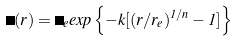<formula> <loc_0><loc_0><loc_500><loc_500>\Sigma ( r ) = \Sigma _ { e } e x p \left \{ - k [ ( r / r _ { e } ) ^ { 1 / n } - 1 ] \right \}</formula> 